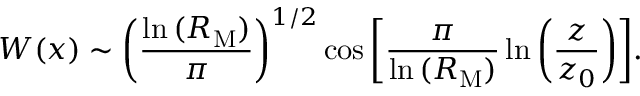Convert formula to latex. <formula><loc_0><loc_0><loc_500><loc_500>W ( x ) \sim \left ( \frac { \ln { ( R _ { M } ) } } { \pi } \right ) ^ { 1 / 2 } \cos { \left [ \frac { \pi } { \ln { ( R _ { M } ) } } \ln { \left ( \frac { z } { z _ { 0 } } \right ) } \right ] } .</formula> 